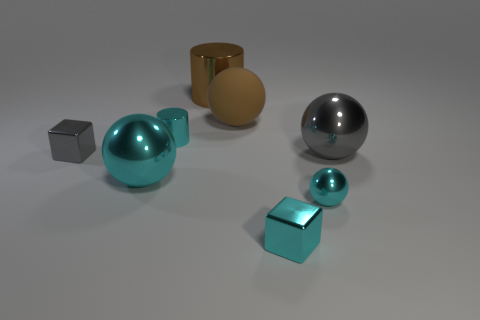The other gray object that is the same shape as the rubber object is what size?
Provide a succinct answer. Large. There is a large object that is the same color as the big matte sphere; what is it made of?
Give a very brief answer. Metal. How many metal objects are the same color as the small metal ball?
Your answer should be compact. 3. What is the size of the cylinder that is in front of the large brown shiny cylinder?
Your answer should be very brief. Small. There is a small cyan thing on the right side of the cyan cube; is there a tiny cyan metallic object that is behind it?
Keep it short and to the point. Yes. What number of other things are the same shape as the matte thing?
Give a very brief answer. 3. Is the large brown matte thing the same shape as the brown metallic thing?
Your answer should be compact. No. What is the color of the sphere that is both on the right side of the large brown rubber thing and behind the tiny sphere?
Make the answer very short. Gray. There is a shiny block that is the same color as the small metallic sphere; what size is it?
Offer a terse response. Small. What number of small things are gray balls or brown objects?
Provide a succinct answer. 0. 